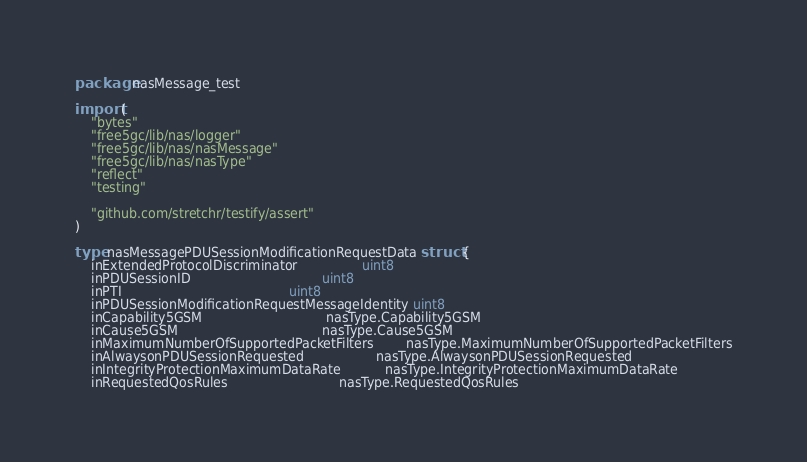Convert code to text. <code><loc_0><loc_0><loc_500><loc_500><_Go_>package nasMessage_test

import (
	"bytes"
	"free5gc/lib/nas/logger"
	"free5gc/lib/nas/nasMessage"
	"free5gc/lib/nas/nasType"
	"reflect"
	"testing"

	"github.com/stretchr/testify/assert"
)

type nasMessagePDUSessionModificationRequestData struct {
	inExtendedProtocolDiscriminator                uint8
	inPDUSessionID                                 uint8
	inPTI                                          uint8
	inPDUSessionModificationRequestMessageIdentity uint8
	inCapability5GSM                               nasType.Capability5GSM
	inCause5GSM                                    nasType.Cause5GSM
	inMaximumNumberOfSupportedPacketFilters        nasType.MaximumNumberOfSupportedPacketFilters
	inAlwaysonPDUSessionRequested                  nasType.AlwaysonPDUSessionRequested
	inIntegrityProtectionMaximumDataRate           nasType.IntegrityProtectionMaximumDataRate
	inRequestedQosRules                            nasType.RequestedQosRules</code> 